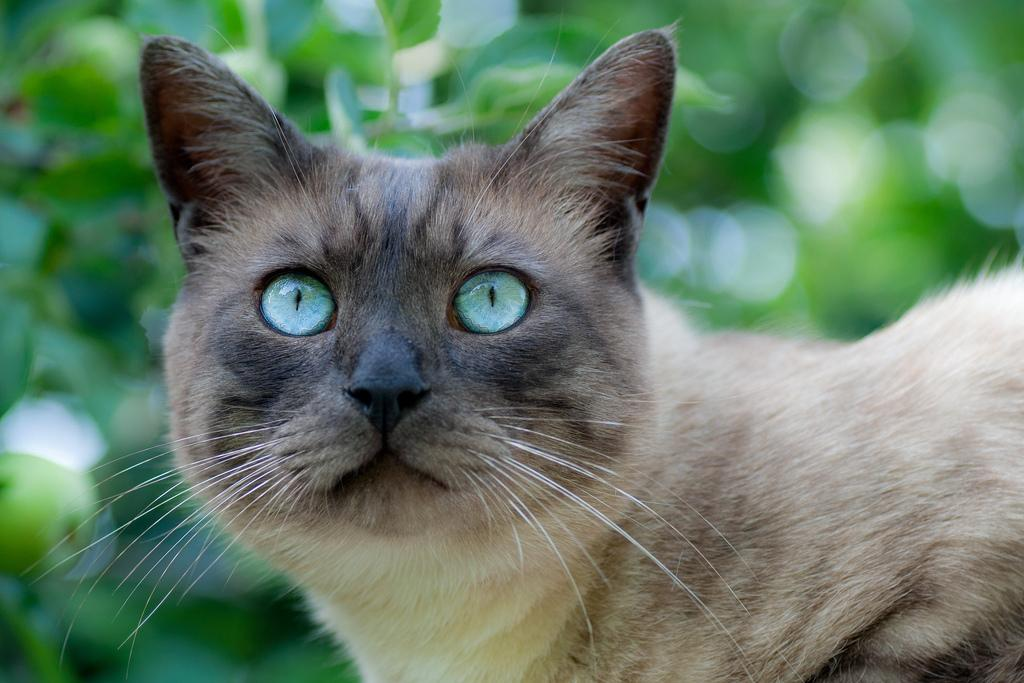What type of animal is in the image? There is a cat in the image. What else can be seen in the image besides the cat? Plants are visible in the image. What is the relation between the cat and the governor in the image? There is no governor present in the image, so it is not possible to determine any relation between the cat and a governor. 